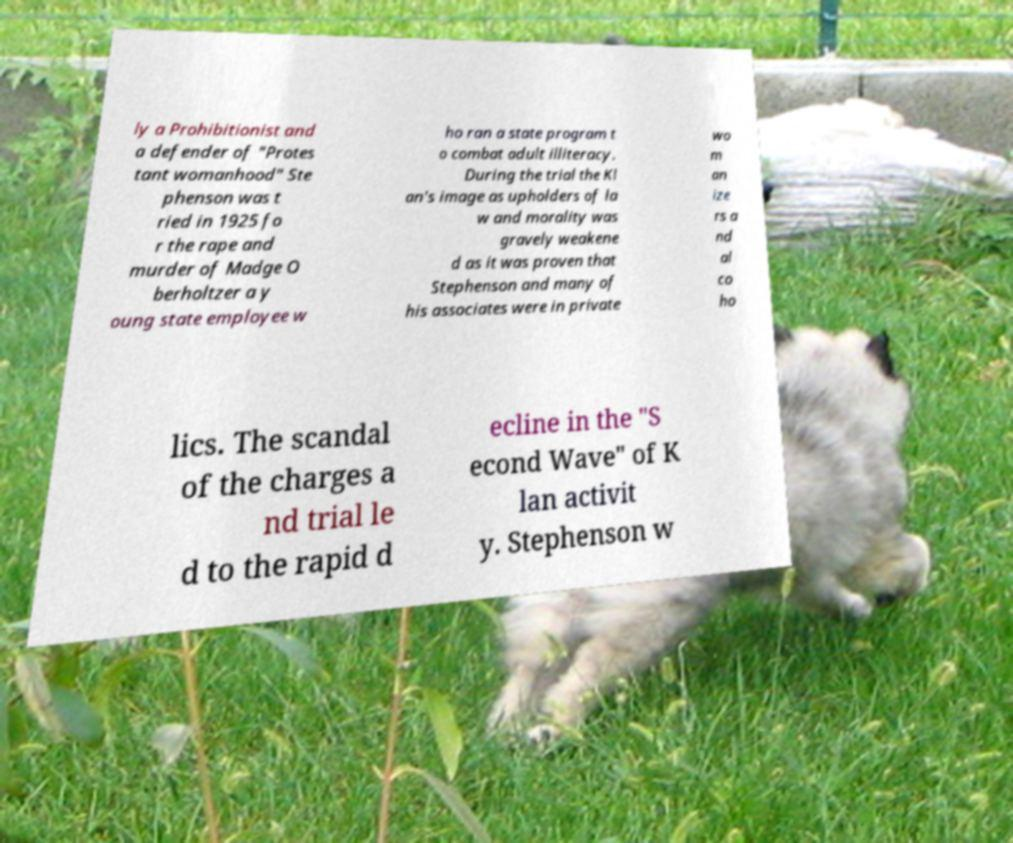What messages or text are displayed in this image? I need them in a readable, typed format. ly a Prohibitionist and a defender of "Protes tant womanhood" Ste phenson was t ried in 1925 fo r the rape and murder of Madge O berholtzer a y oung state employee w ho ran a state program t o combat adult illiteracy. During the trial the Kl an's image as upholders of la w and morality was gravely weakene d as it was proven that Stephenson and many of his associates were in private wo m an ize rs a nd al co ho lics. The scandal of the charges a nd trial le d to the rapid d ecline in the "S econd Wave" of K lan activit y. Stephenson w 